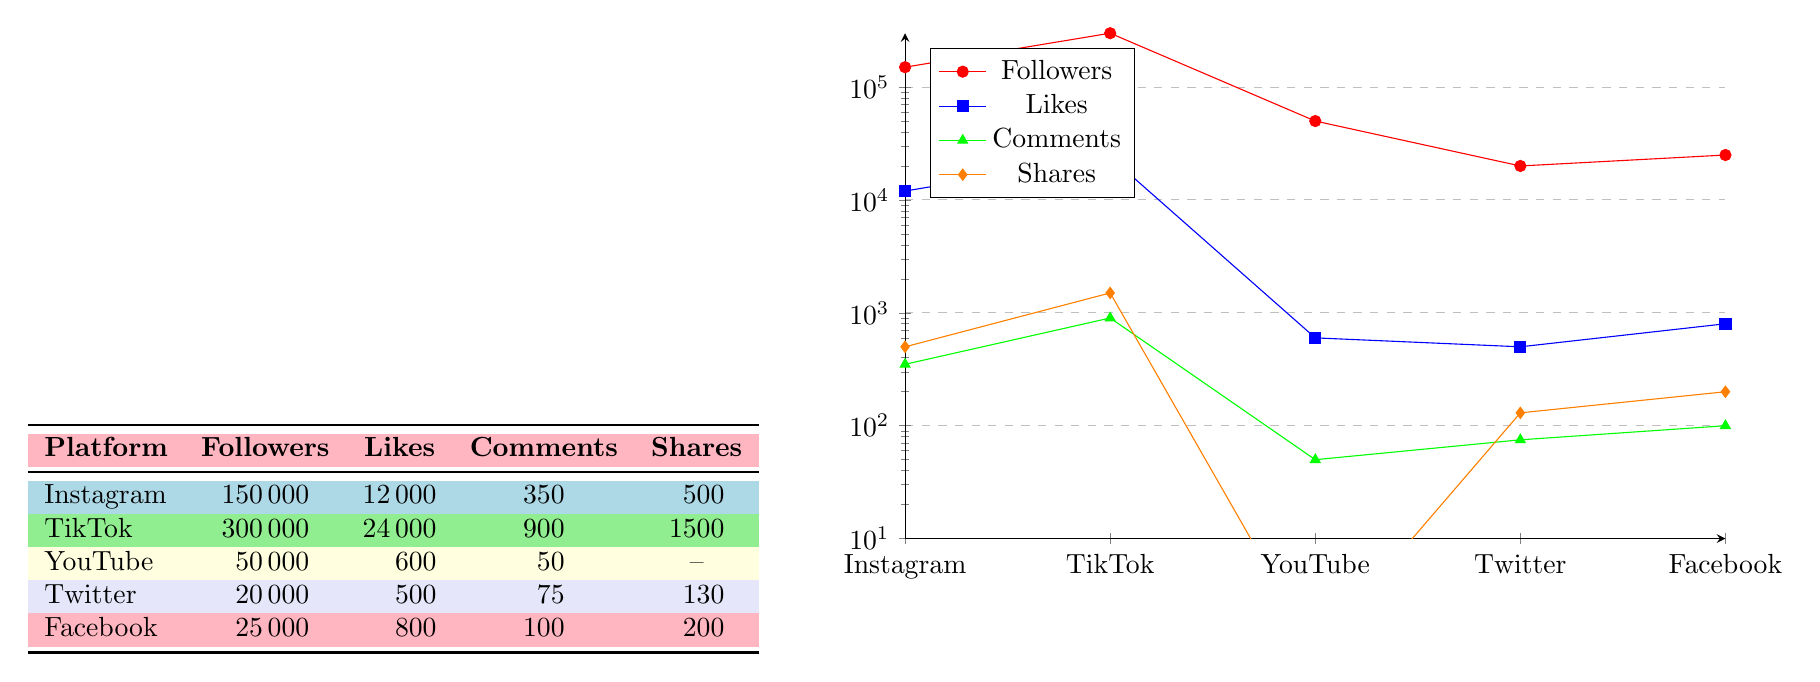What is the total number of followers across all platforms? To find the total number of followers, we sum the followers from each platform: 150000 (Instagram) + 300000 (TikTok) + 50000 (YouTube) + 20000 (Twitter) + 25000 (Facebook) = 525000.
Answer: 525000 Which platform has the highest likes per post? By comparing the likes per post from each platform, TikTok has 24000 likes per video, which is greater than Instagram's 12000 likes per post, YouTube's 600 likes per video, Twitter's 500 likes per tweet, and Facebook's 800 likes per post.
Answer: TikTok What is the average number of comments per post across all platforms that have comments? We calculate the average by summing the comments per post and dividing by the number of platforms that have comments: (350 (Instagram) + 900 (TikTok) + 50 (YouTube) + 75 (Twitter) + 100 (Facebook)) = 1575. There are 5 platforms in total, so the average is 1575/5 = 315.
Answer: 315 Is it true that Facebook has more likes per post than Twitter? By looking at the likes per post for each platform, Facebook has 800 likes per post while Twitter has 500 likes per tweet. Since 800 is greater than 500, the statement is true.
Answer: Yes What is the difference in shares per post between TikTok and Instagram? TikTok has 1500 shares per video, and Instagram has 500 shares per post. The difference is calculated as 1500 - 500 = 1000.
Answer: 1000 What is the total average number of likes per post for Instagram, TikTok, and Facebook combined? The total number of likes for these three platforms is 12000 (Instagram) + 24000 (TikTok) + 800 (Facebook) = 36800. The average is then calculated by dividing this sum by 3 (the number of platforms), so 36800/3 = approximately 12266.67.
Answer: 12266.67 Which platform has the least engagement in terms of shares per post? Looking at the shares per post, we see that YouTube does not have any recorded shares, while Twitter has 130 and Facebook has 200. Therefore, YouTube has the least engagement in shares.
Answer: YouTube How many more followers does TikTok have than Instagram? TikTok has 300000 followers and Instagram has 150000 followers. The difference is calculated as 300000 - 150000 = 150000.
Answer: 150000 